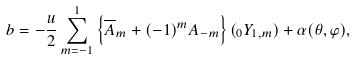<formula> <loc_0><loc_0><loc_500><loc_500>b = - \frac { u } { 2 } \sum ^ { 1 } _ { m = - 1 } \left \{ \overline { A } _ { m } + ( - 1 ) ^ { m } { A } _ { - m } \right \} ( _ { 0 } Y _ { 1 , m } ) + \alpha ( \theta , \varphi ) ,</formula> 